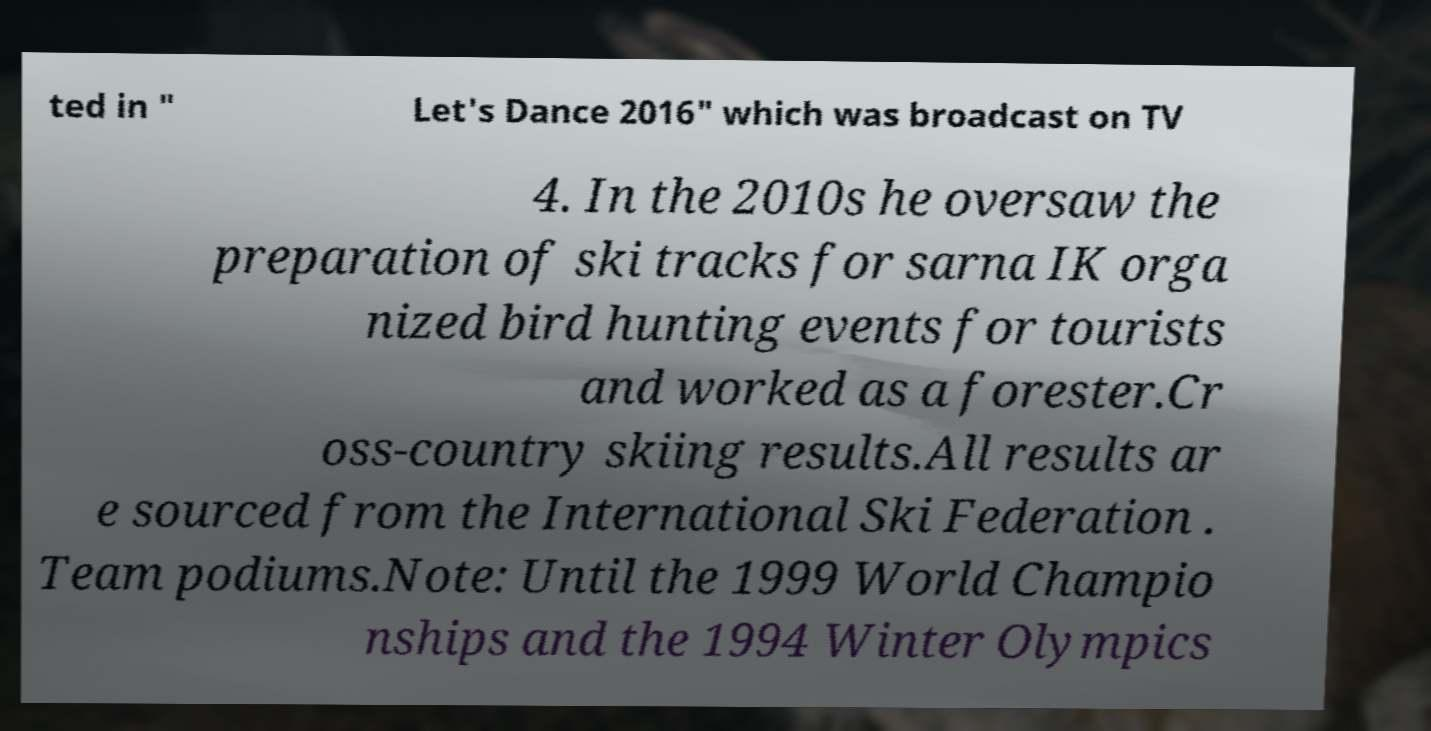What messages or text are displayed in this image? I need them in a readable, typed format. ted in " Let's Dance 2016" which was broadcast on TV 4. In the 2010s he oversaw the preparation of ski tracks for sarna IK orga nized bird hunting events for tourists and worked as a forester.Cr oss-country skiing results.All results ar e sourced from the International Ski Federation . Team podiums.Note: Until the 1999 World Champio nships and the 1994 Winter Olympics 